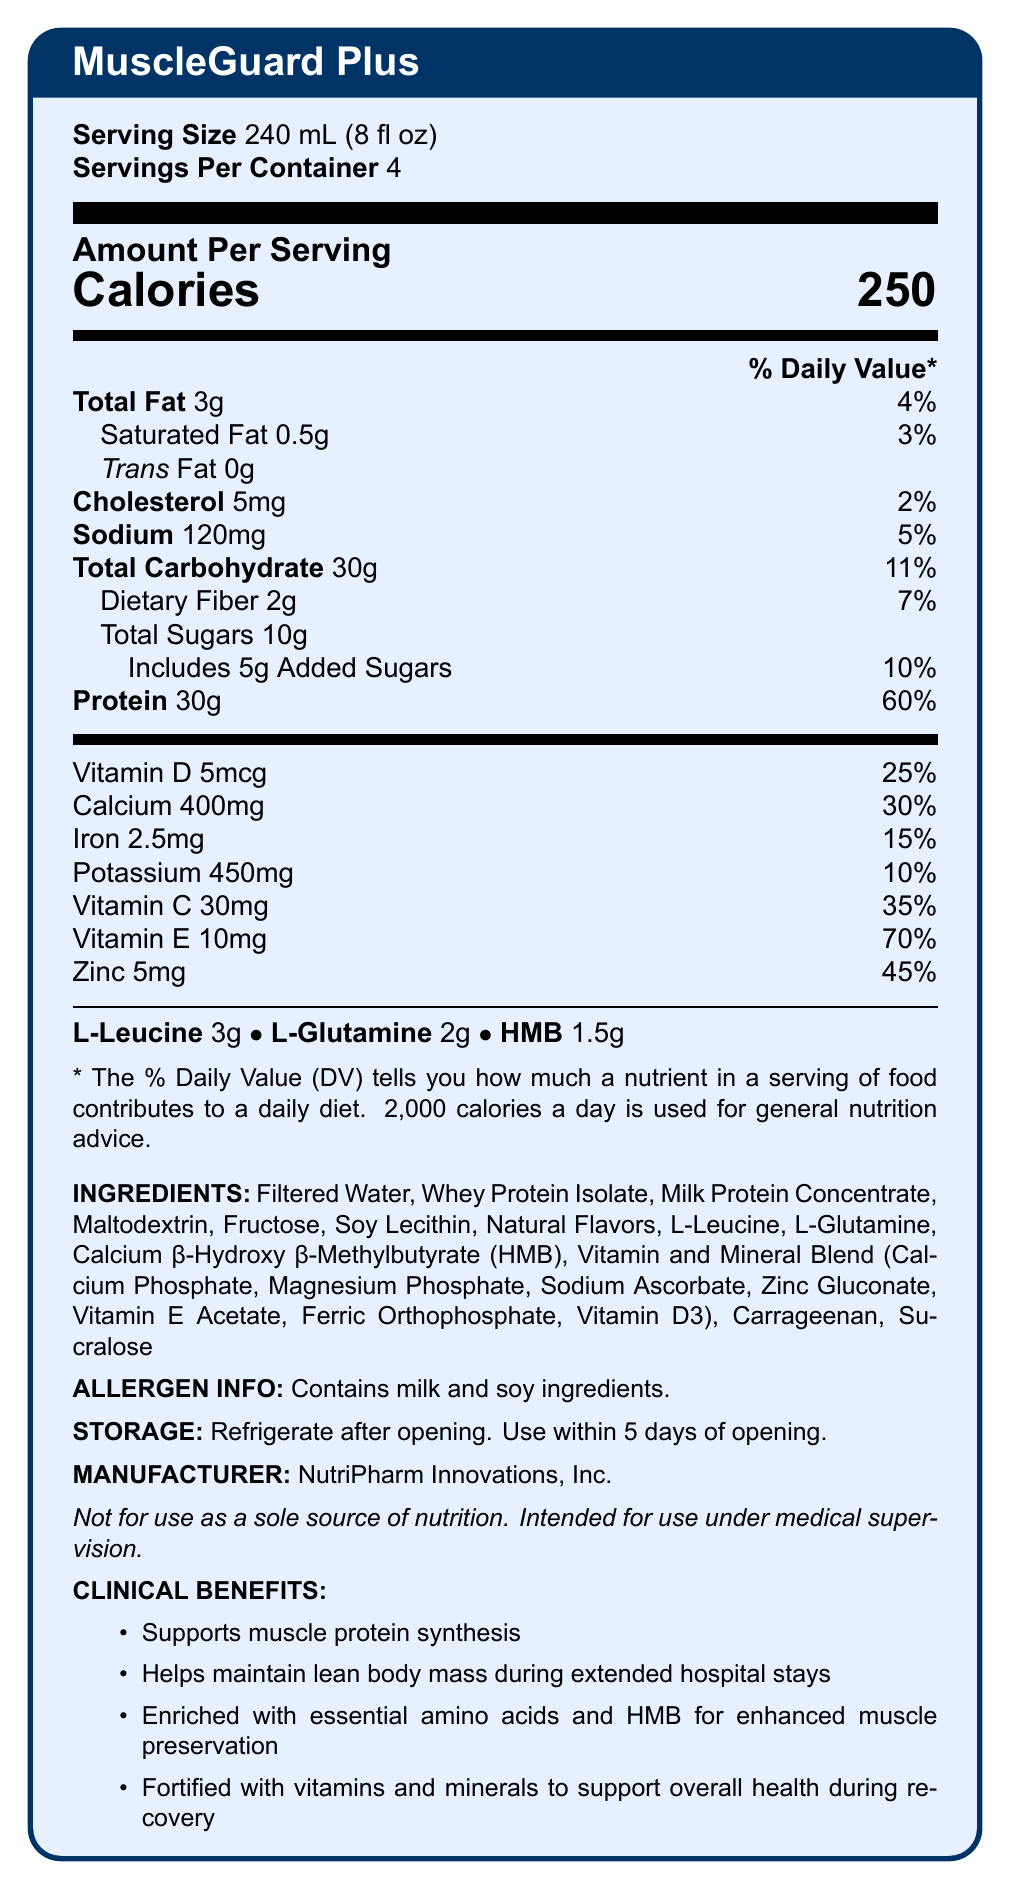what is the serving size for MuscleGuard Plus? The serving size is listed at the very beginning of the document under "Serving Size."
Answer: 240 mL (8 fl oz) how many servings are in one container? The number of servings per container is provided right next to the serving size information.
Answer: 4 what is the total calorie count per serving? The document lists "Calories" with a value of 250.
Answer: 250 how much protein does each serving contain? The protein amount is specified in the nutritional information section as "Protein 30g."
Answer: 30g what ingredients in MuscleGuard Plus might cause allergies? The allergen information section clearly states that the product contains milk and soy ingredients.
Answer: Milk and soy what percentage of the daily value for vitamin D is provided per serving? The daily value percentage for vitamin D is listed as 25% next to its amount of 5mcg.
Answer: 25% what is the main idea of the document? The document contains detailed nutrition facts, ingredients, clinical benefits, and other relevant product information.
Answer: It provides the nutritional facts and additional information about MuscleGuard Plus, a protein-fortified beverage aimed at preventing muscle wasting in long-term hospitalized patients. which vitamin has the highest daily value percentage per serving? A. Vitamin C B. Vitamin D C. Vitamin E D. Zinc Vitamin E is listed with a 70% daily value, the highest among the vitamins and minerals listed.
Answer: C. Vitamin E how much L-Leucine is in each serving? A. 1g B. 2g C. 3g D. 4g The document mentions that each serving contains 3g of L-Leucine.
Answer: C. 3g does MuscleGuard Plus support muscle protein synthesis? One of the clinical benefits listed is that the product supports muscle protein synthesis.
Answer: Yes how many grams of added sugars does each serving have? The amount of added sugars is indicated under the total sugars section as "Includes 5g Added Sugars."
Answer: 5g what is the source of the protein in MuscleGuard Plus? The ingredients list shows that the protein comes from whey protein isolate and milk protein concentrate.
Answer: Whey Protein Isolate and Milk Protein Concentrate is the product suitable for use as a sole source of nutrition? The statement at the end of the document explicitly says, "Not for use as a sole source of nutrition."
Answer: No how long can MuscleGuard Plus be used after opening, provided it is refrigerated? The storage section indicates that the product should be used within 5 days of opening, provided it is refrigerated.
Answer: 5 days who manufactures MuscleGuard Plus? The manufacturer's name is listed towards the end of the document.
Answer: NutriPharm Innovations, Inc. what are the clinical benefits of MuscleGuard Plus? This information is presented under the "Clinical Benefits" section.
Answer: Supports muscle protein synthesis, helps maintain lean body mass during extended hospital stays, enriched with essential amino acids and HMB for enhanced muscle preservation, fortified with vitamins and minerals to support overall health during recovery where is the daily value information for dietary fiber located? The dietary fiber daily value percentage is listed in the nutritional information table as 7%.
Answer: 7% how much cholesterol is present in a serving of MuscleGuard Plus? The amount of cholesterol per serving is listed as 5mg.
Answer: 5mg what is the primary carbohydrate source in MuscleGuard Plus? The ingredients list mentions maltodextrin as one of the carbohydrate sources.
Answer: Maltodextrin is the document sufficient to determine if the beverage contains any artificial colors? The document lists ingredients but does not specifically address the presence or absence of artificial colors.
Answer: Not enough information 